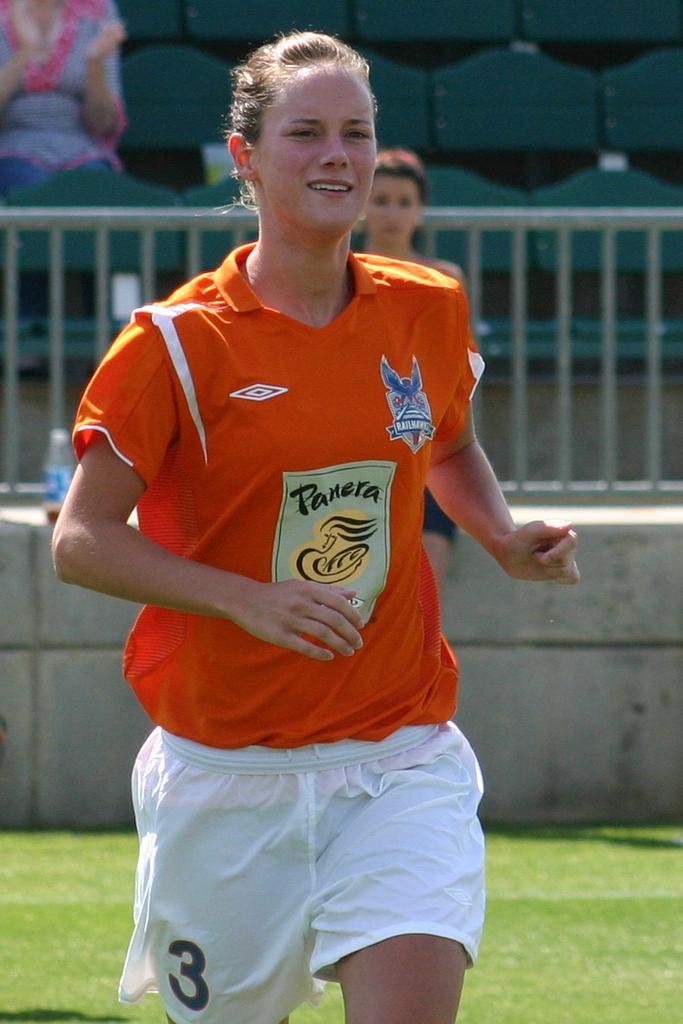<image>
Give a short and clear explanation of the subsequent image. A female soccer player wears an orange jersey with an advertisement for Panera on it. 